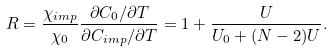Convert formula to latex. <formula><loc_0><loc_0><loc_500><loc_500>R = \frac { \chi _ { i m p } } { \chi _ { 0 } } \frac { \partial C _ { 0 } / \partial T } { \partial C _ { i m p } / \partial T } = 1 + \frac { U } { U _ { 0 } + ( N - 2 ) U } .</formula> 